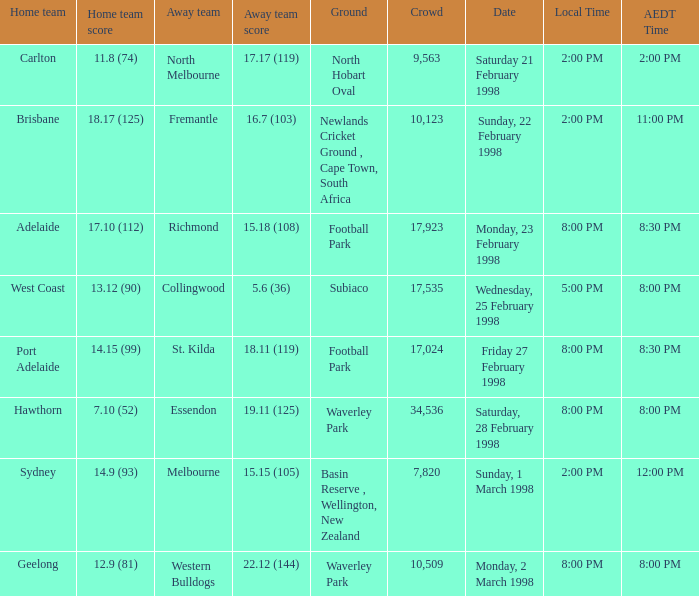Can you parse all the data within this table? {'header': ['Home team', 'Home team score', 'Away team', 'Away team score', 'Ground', 'Crowd', 'Date', 'Local Time', 'AEDT Time'], 'rows': [['Carlton', '11.8 (74)', 'North Melbourne', '17.17 (119)', 'North Hobart Oval', '9,563', 'Saturday 21 February 1998', '2:00 PM', '2:00 PM'], ['Brisbane', '18.17 (125)', 'Fremantle', '16.7 (103)', 'Newlands Cricket Ground , Cape Town, South Africa', '10,123', 'Sunday, 22 February 1998', '2:00 PM', '11:00 PM'], ['Adelaide', '17.10 (112)', 'Richmond', '15.18 (108)', 'Football Park', '17,923', 'Monday, 23 February 1998', '8:00 PM', '8:30 PM'], ['West Coast', '13.12 (90)', 'Collingwood', '5.6 (36)', 'Subiaco', '17,535', 'Wednesday, 25 February 1998', '5:00 PM', '8:00 PM'], ['Port Adelaide', '14.15 (99)', 'St. Kilda', '18.11 (119)', 'Football Park', '17,024', 'Friday 27 February 1998', '8:00 PM', '8:30 PM'], ['Hawthorn', '7.10 (52)', 'Essendon', '19.11 (125)', 'Waverley Park', '34,536', 'Saturday, 28 February 1998', '8:00 PM', '8:00 PM'], ['Sydney', '14.9 (93)', 'Melbourne', '15.15 (105)', 'Basin Reserve , Wellington, New Zealand', '7,820', 'Sunday, 1 March 1998', '2:00 PM', '12:00 PM'], ['Geelong', '12.9 (81)', 'Western Bulldogs', '22.12 (144)', 'Waverley Park', '10,509', 'Monday, 2 March 1998', '8:00 PM', '8:00 PM']]} Specify the aedt time featuring an away team of collingwood? 8:00 PM. 